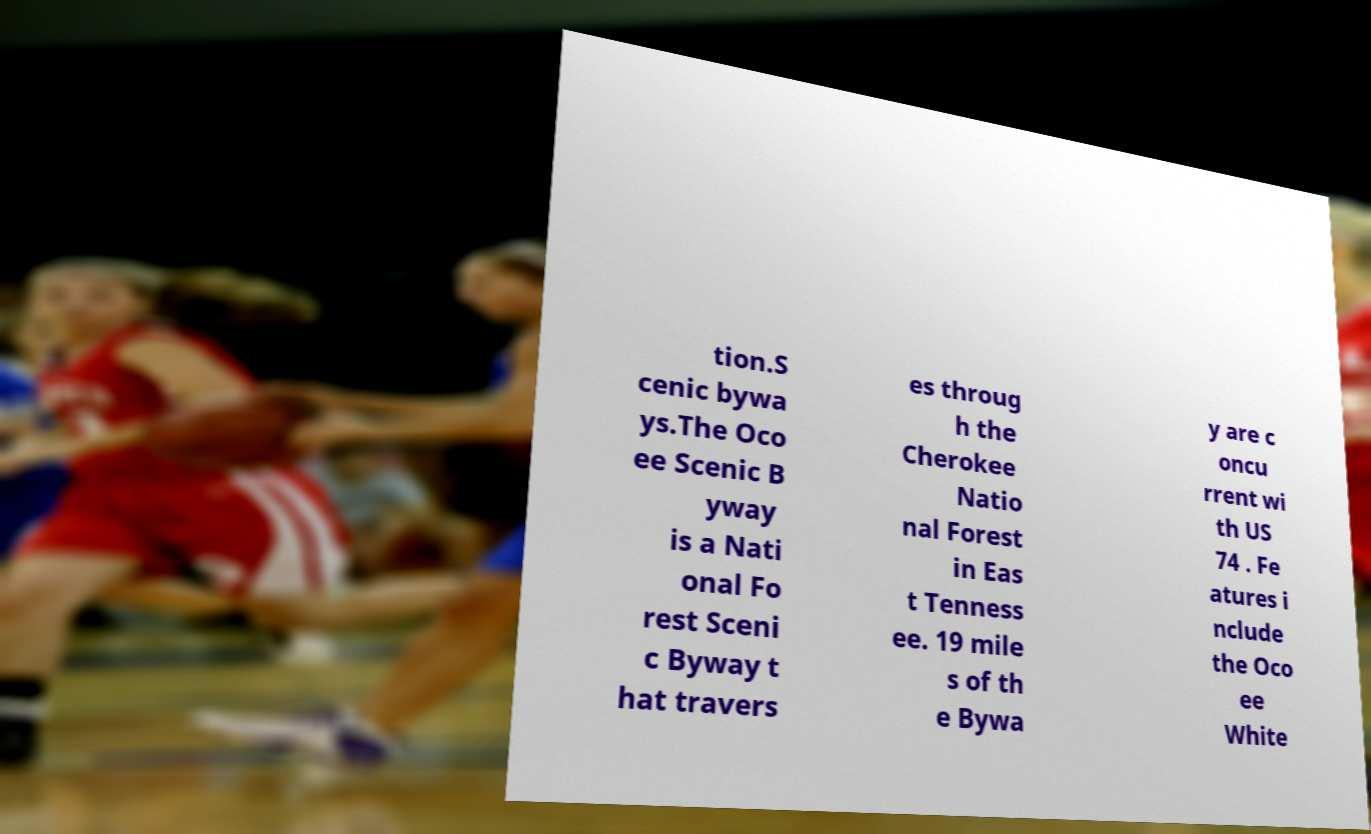There's text embedded in this image that I need extracted. Can you transcribe it verbatim? tion.S cenic bywa ys.The Oco ee Scenic B yway is a Nati onal Fo rest Sceni c Byway t hat travers es throug h the Cherokee Natio nal Forest in Eas t Tenness ee. 19 mile s of th e Bywa y are c oncu rrent wi th US 74 . Fe atures i nclude the Oco ee White 